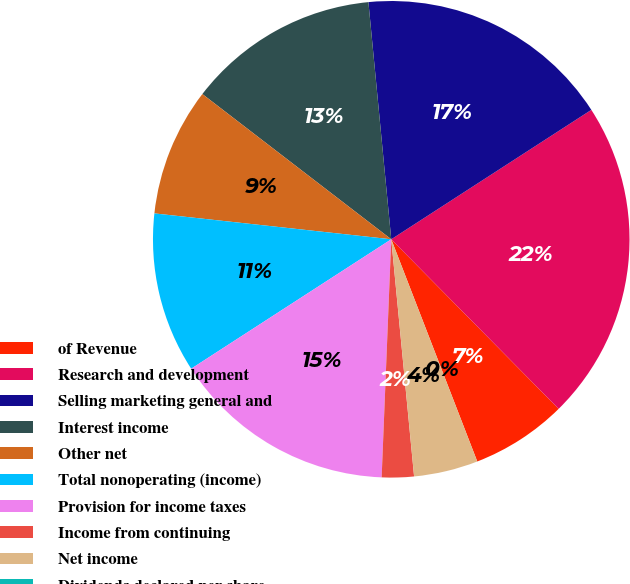Convert chart to OTSL. <chart><loc_0><loc_0><loc_500><loc_500><pie_chart><fcel>of Revenue<fcel>Research and development<fcel>Selling marketing general and<fcel>Interest income<fcel>Other net<fcel>Total nonoperating (income)<fcel>Provision for income taxes<fcel>Income from continuing<fcel>Net income<fcel>Dividends declared per share<nl><fcel>6.52%<fcel>21.74%<fcel>17.39%<fcel>13.04%<fcel>8.7%<fcel>10.87%<fcel>15.22%<fcel>2.17%<fcel>4.35%<fcel>0.0%<nl></chart> 